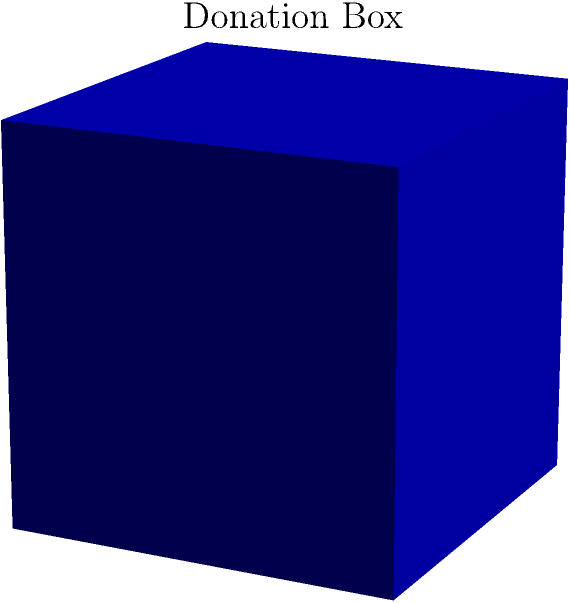A local community center is planning to place cube-shaped donation boxes for their outreach program. If each side of the box measures $a$ units, and they need to cover the entire surface with inspirational messages, what is the total surface area they need to design for? To find the surface area of a cube, we need to follow these steps:

1. Identify the length of one side of the cube: $a$ units

2. Recall the formula for the surface area of a cube:
   Surface Area = 6 * (side length)²

3. Substitute the side length into the formula:
   Surface Area = 6 * $a$²

4. This expression, 6$a$², represents the total surface area of the cube-shaped donation box.

The community center will need to design inspirational messages to cover this entire surface area, ensuring that all sides of the donation box contribute to spreading positivity and encouraging support for the outreach program.
Answer: 6$a$² square units 